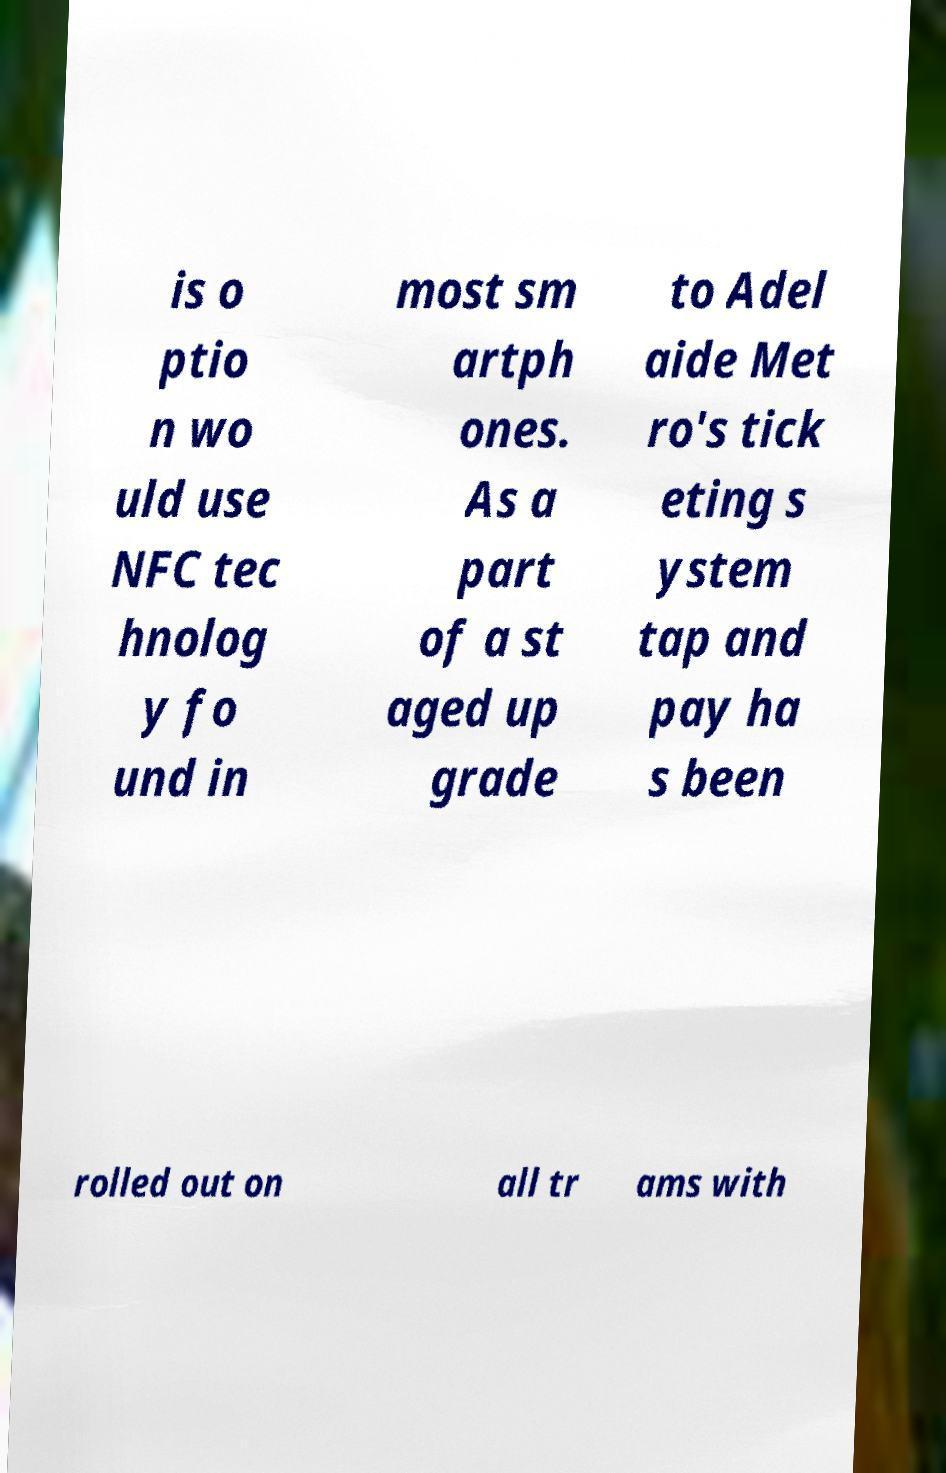What messages or text are displayed in this image? I need them in a readable, typed format. is o ptio n wo uld use NFC tec hnolog y fo und in most sm artph ones. As a part of a st aged up grade to Adel aide Met ro's tick eting s ystem tap and pay ha s been rolled out on all tr ams with 